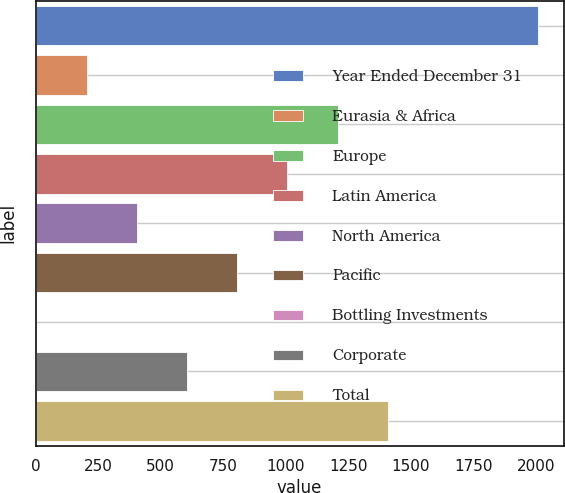<chart> <loc_0><loc_0><loc_500><loc_500><bar_chart><fcel>Year Ended December 31<fcel>Eurasia & Africa<fcel>Europe<fcel>Latin America<fcel>North America<fcel>Pacific<fcel>Bottling Investments<fcel>Corporate<fcel>Total<nl><fcel>2010<fcel>203.43<fcel>1207.08<fcel>1006.35<fcel>404.16<fcel>805.62<fcel>2.7<fcel>604.89<fcel>1407.81<nl></chart> 